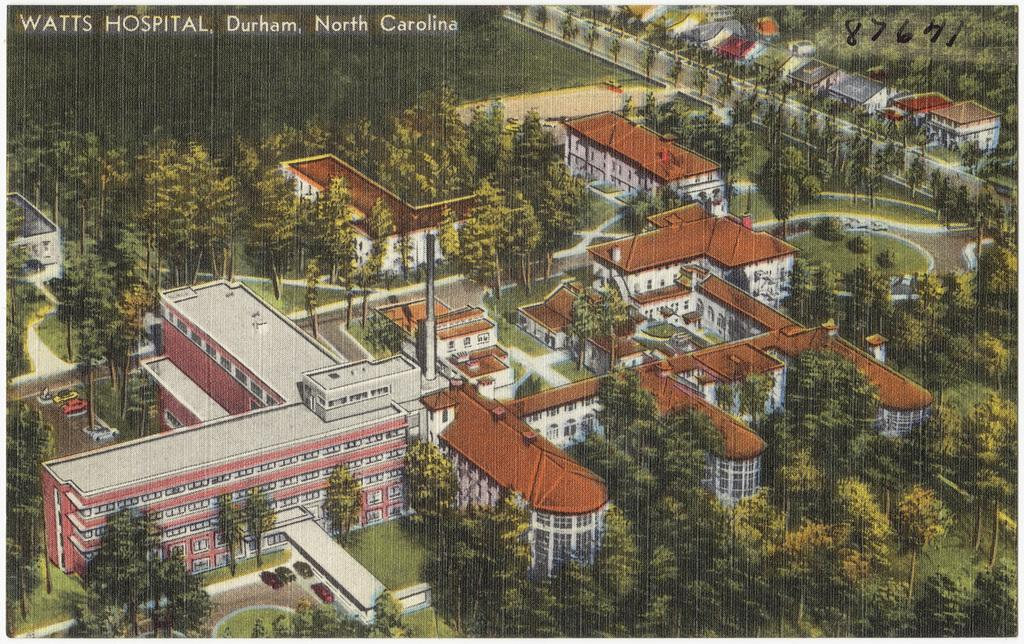What type of vegetation can be seen in the image? There is a group of trees in the image. What structures are present in the image? There are buildings in the image. What type of vehicles can be seen in the image? There are cars in the image. What type of ground cover is visible in the image? There is grass visible in the image. What is written or displayed at the top of the image? There is text at the top of the image. Where is the cave located in the image? There is no cave present in the image. What type of hall can be seen in the image? There is no hall present in the image. 